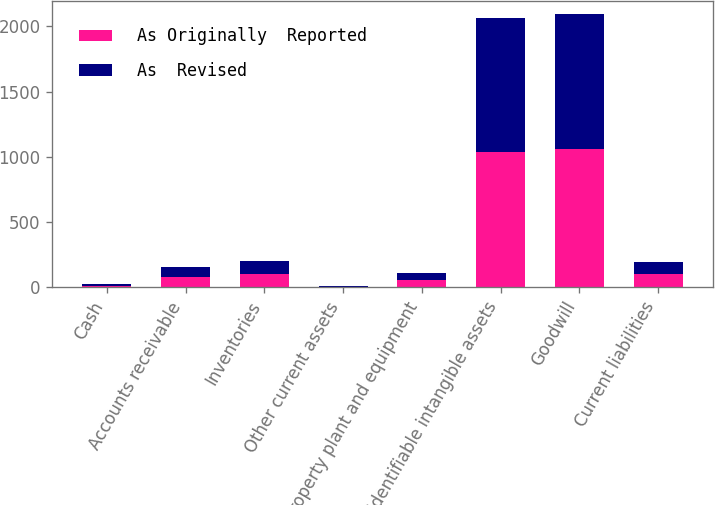Convert chart to OTSL. <chart><loc_0><loc_0><loc_500><loc_500><stacked_bar_chart><ecel><fcel>Cash<fcel>Accounts receivable<fcel>Inventories<fcel>Other current assets<fcel>Property plant and equipment<fcel>Identifiable intangible assets<fcel>Goodwill<fcel>Current liabilities<nl><fcel>As Originally  Reported<fcel>11.8<fcel>75.9<fcel>102.4<fcel>2.9<fcel>53.4<fcel>1033.8<fcel>1061.9<fcel>97.2<nl><fcel>As  Revised<fcel>11.8<fcel>75.9<fcel>101.8<fcel>2.8<fcel>53.1<fcel>1033.8<fcel>1031<fcel>94.7<nl></chart> 